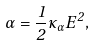Convert formula to latex. <formula><loc_0><loc_0><loc_500><loc_500>\alpha = \frac { 1 } { 2 } \kappa _ { \alpha } E ^ { 2 } ,</formula> 